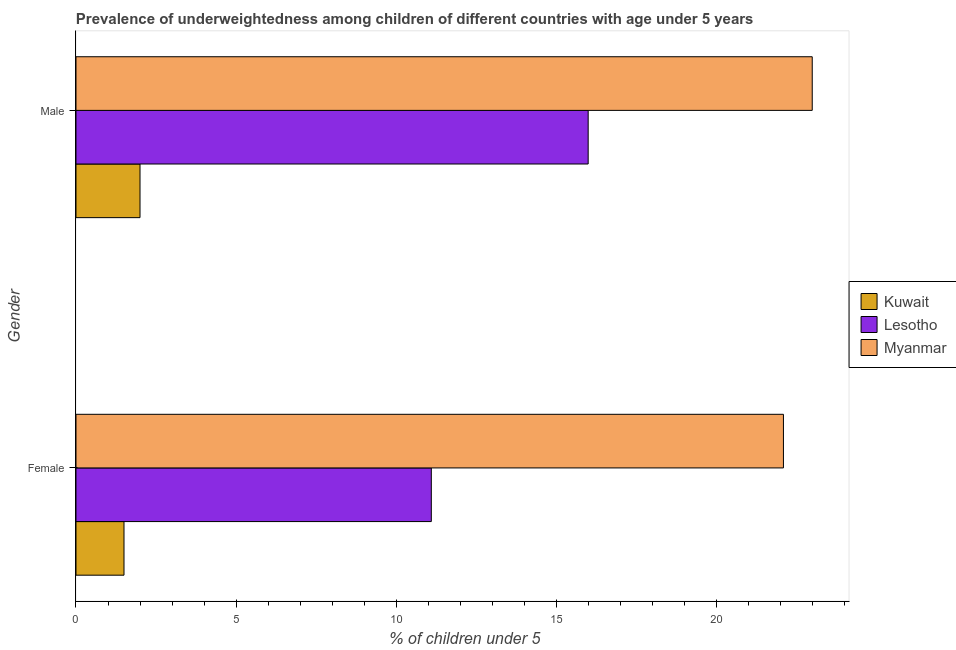How many different coloured bars are there?
Provide a short and direct response. 3. How many groups of bars are there?
Make the answer very short. 2. Are the number of bars on each tick of the Y-axis equal?
Offer a very short reply. Yes. How many bars are there on the 1st tick from the top?
Ensure brevity in your answer.  3. What is the label of the 2nd group of bars from the top?
Ensure brevity in your answer.  Female. What is the percentage of underweighted female children in Kuwait?
Offer a terse response. 1.5. Across all countries, what is the maximum percentage of underweighted female children?
Your answer should be very brief. 22.1. Across all countries, what is the minimum percentage of underweighted female children?
Provide a succinct answer. 1.5. In which country was the percentage of underweighted female children maximum?
Your response must be concise. Myanmar. In which country was the percentage of underweighted male children minimum?
Your response must be concise. Kuwait. What is the total percentage of underweighted female children in the graph?
Offer a very short reply. 34.7. What is the difference between the percentage of underweighted male children in Myanmar and that in Lesotho?
Give a very brief answer. 7. What is the difference between the percentage of underweighted male children in Kuwait and the percentage of underweighted female children in Lesotho?
Provide a short and direct response. -9.1. What is the average percentage of underweighted female children per country?
Give a very brief answer. 11.57. What is the difference between the percentage of underweighted male children and percentage of underweighted female children in Lesotho?
Offer a terse response. 4.9. What is the ratio of the percentage of underweighted male children in Lesotho to that in Myanmar?
Your answer should be compact. 0.7. What does the 3rd bar from the top in Male represents?
Ensure brevity in your answer.  Kuwait. What does the 3rd bar from the bottom in Female represents?
Your response must be concise. Myanmar. Are all the bars in the graph horizontal?
Offer a terse response. Yes. How many countries are there in the graph?
Offer a very short reply. 3. What is the difference between two consecutive major ticks on the X-axis?
Your answer should be very brief. 5. Does the graph contain grids?
Give a very brief answer. No. What is the title of the graph?
Keep it short and to the point. Prevalence of underweightedness among children of different countries with age under 5 years. What is the label or title of the X-axis?
Keep it short and to the point.  % of children under 5. What is the  % of children under 5 in Lesotho in Female?
Your response must be concise. 11.1. What is the  % of children under 5 in Myanmar in Female?
Your response must be concise. 22.1. What is the  % of children under 5 in Kuwait in Male?
Offer a very short reply. 2. What is the  % of children under 5 of Lesotho in Male?
Ensure brevity in your answer.  16. What is the  % of children under 5 in Myanmar in Male?
Ensure brevity in your answer.  23. Across all Gender, what is the maximum  % of children under 5 in Kuwait?
Offer a terse response. 2. Across all Gender, what is the maximum  % of children under 5 of Lesotho?
Provide a succinct answer. 16. Across all Gender, what is the minimum  % of children under 5 of Lesotho?
Ensure brevity in your answer.  11.1. Across all Gender, what is the minimum  % of children under 5 in Myanmar?
Give a very brief answer. 22.1. What is the total  % of children under 5 of Lesotho in the graph?
Provide a succinct answer. 27.1. What is the total  % of children under 5 of Myanmar in the graph?
Ensure brevity in your answer.  45.1. What is the difference between the  % of children under 5 of Kuwait in Female and that in Male?
Provide a short and direct response. -0.5. What is the difference between the  % of children under 5 of Lesotho in Female and that in Male?
Your answer should be compact. -4.9. What is the difference between the  % of children under 5 of Myanmar in Female and that in Male?
Keep it short and to the point. -0.9. What is the difference between the  % of children under 5 in Kuwait in Female and the  % of children under 5 in Myanmar in Male?
Keep it short and to the point. -21.5. What is the difference between the  % of children under 5 in Lesotho in Female and the  % of children under 5 in Myanmar in Male?
Make the answer very short. -11.9. What is the average  % of children under 5 of Kuwait per Gender?
Provide a succinct answer. 1.75. What is the average  % of children under 5 of Lesotho per Gender?
Your answer should be compact. 13.55. What is the average  % of children under 5 in Myanmar per Gender?
Your answer should be compact. 22.55. What is the difference between the  % of children under 5 in Kuwait and  % of children under 5 in Lesotho in Female?
Make the answer very short. -9.6. What is the difference between the  % of children under 5 in Kuwait and  % of children under 5 in Myanmar in Female?
Give a very brief answer. -20.6. What is the difference between the  % of children under 5 of Kuwait and  % of children under 5 of Lesotho in Male?
Your answer should be very brief. -14. What is the ratio of the  % of children under 5 in Lesotho in Female to that in Male?
Give a very brief answer. 0.69. What is the ratio of the  % of children under 5 in Myanmar in Female to that in Male?
Offer a terse response. 0.96. What is the difference between the highest and the second highest  % of children under 5 of Kuwait?
Offer a terse response. 0.5. What is the difference between the highest and the second highest  % of children under 5 of Lesotho?
Make the answer very short. 4.9. What is the difference between the highest and the second highest  % of children under 5 of Myanmar?
Your answer should be very brief. 0.9. What is the difference between the highest and the lowest  % of children under 5 of Kuwait?
Your response must be concise. 0.5. What is the difference between the highest and the lowest  % of children under 5 of Lesotho?
Your response must be concise. 4.9. What is the difference between the highest and the lowest  % of children under 5 in Myanmar?
Give a very brief answer. 0.9. 